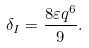Convert formula to latex. <formula><loc_0><loc_0><loc_500><loc_500>\delta _ { I } = \frac { 8 \varepsilon q ^ { 6 } } { 9 } .</formula> 